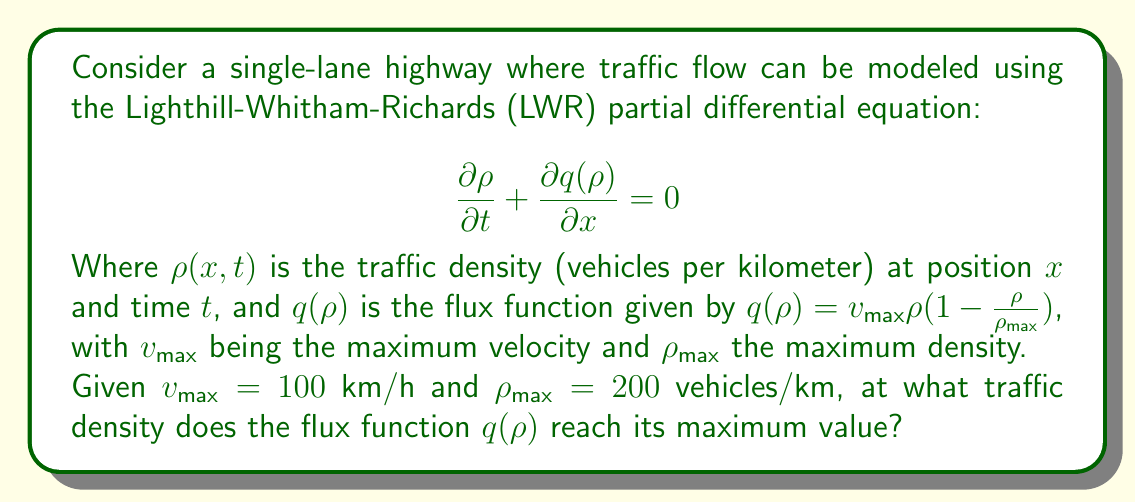Give your solution to this math problem. To solve this problem, we need to follow these steps:

1) First, let's write out the flux function with the given parameters:

   $$q(\rho) = 100\rho(1-\frac{\rho}{200})$$

2) To find the maximum value of this function, we need to differentiate it with respect to $\rho$ and set it equal to zero:

   $$\frac{dq}{d\rho} = 100(1-\frac{\rho}{200}) + 100\rho(-\frac{1}{200}) = 0$$

3) Simplify the equation:

   $$100 - \frac{\rho}{2} - \frac{\rho}{2} = 0$$
   $$100 - \rho = 0$$

4) Solve for $\rho$:

   $$\rho = 100$$

5) To confirm this is a maximum (not a minimum), we can check the second derivative:

   $$\frac{d^2q}{d\rho^2} = -1 < 0$$

   Since the second derivative is negative, this confirms we've found a maximum.

6) We can interpret this result in the context of traffic flow:

   The flux (flow rate) reaches its maximum when the density is half of the maximum density. This makes sense intuitively: if the road is too empty, not many cars pass per hour; if it's too full, cars move slowly. The optimal flow occurs at an intermediate density.
Answer: The flux function $q(\rho)$ reaches its maximum value when the traffic density $\rho = 100$ vehicles/km. 